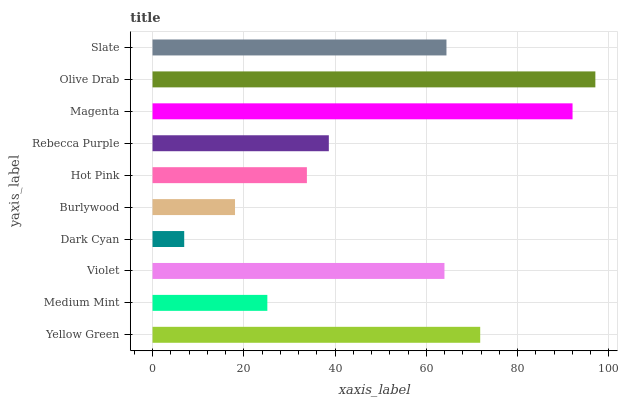Is Dark Cyan the minimum?
Answer yes or no. Yes. Is Olive Drab the maximum?
Answer yes or no. Yes. Is Medium Mint the minimum?
Answer yes or no. No. Is Medium Mint the maximum?
Answer yes or no. No. Is Yellow Green greater than Medium Mint?
Answer yes or no. Yes. Is Medium Mint less than Yellow Green?
Answer yes or no. Yes. Is Medium Mint greater than Yellow Green?
Answer yes or no. No. Is Yellow Green less than Medium Mint?
Answer yes or no. No. Is Violet the high median?
Answer yes or no. Yes. Is Rebecca Purple the low median?
Answer yes or no. Yes. Is Magenta the high median?
Answer yes or no. No. Is Hot Pink the low median?
Answer yes or no. No. 